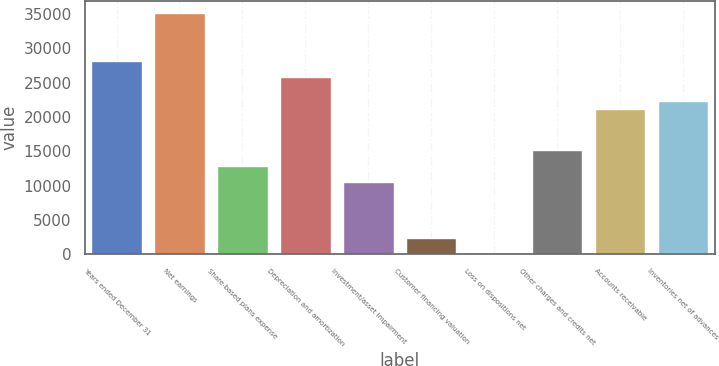<chart> <loc_0><loc_0><loc_500><loc_500><bar_chart><fcel>Years ended December 31<fcel>Net earnings<fcel>Share-based plans expense<fcel>Depreciation and amortization<fcel>Investment/asset impairment<fcel>Customer financing valuation<fcel>Loss on dispositions net<fcel>Other charges and credits net<fcel>Accounts receivable<fcel>Inventories net of advances<nl><fcel>28157.8<fcel>35197<fcel>12906.2<fcel>25811.4<fcel>10559.8<fcel>2347.4<fcel>1<fcel>15252.6<fcel>21118.6<fcel>22291.8<nl></chart> 